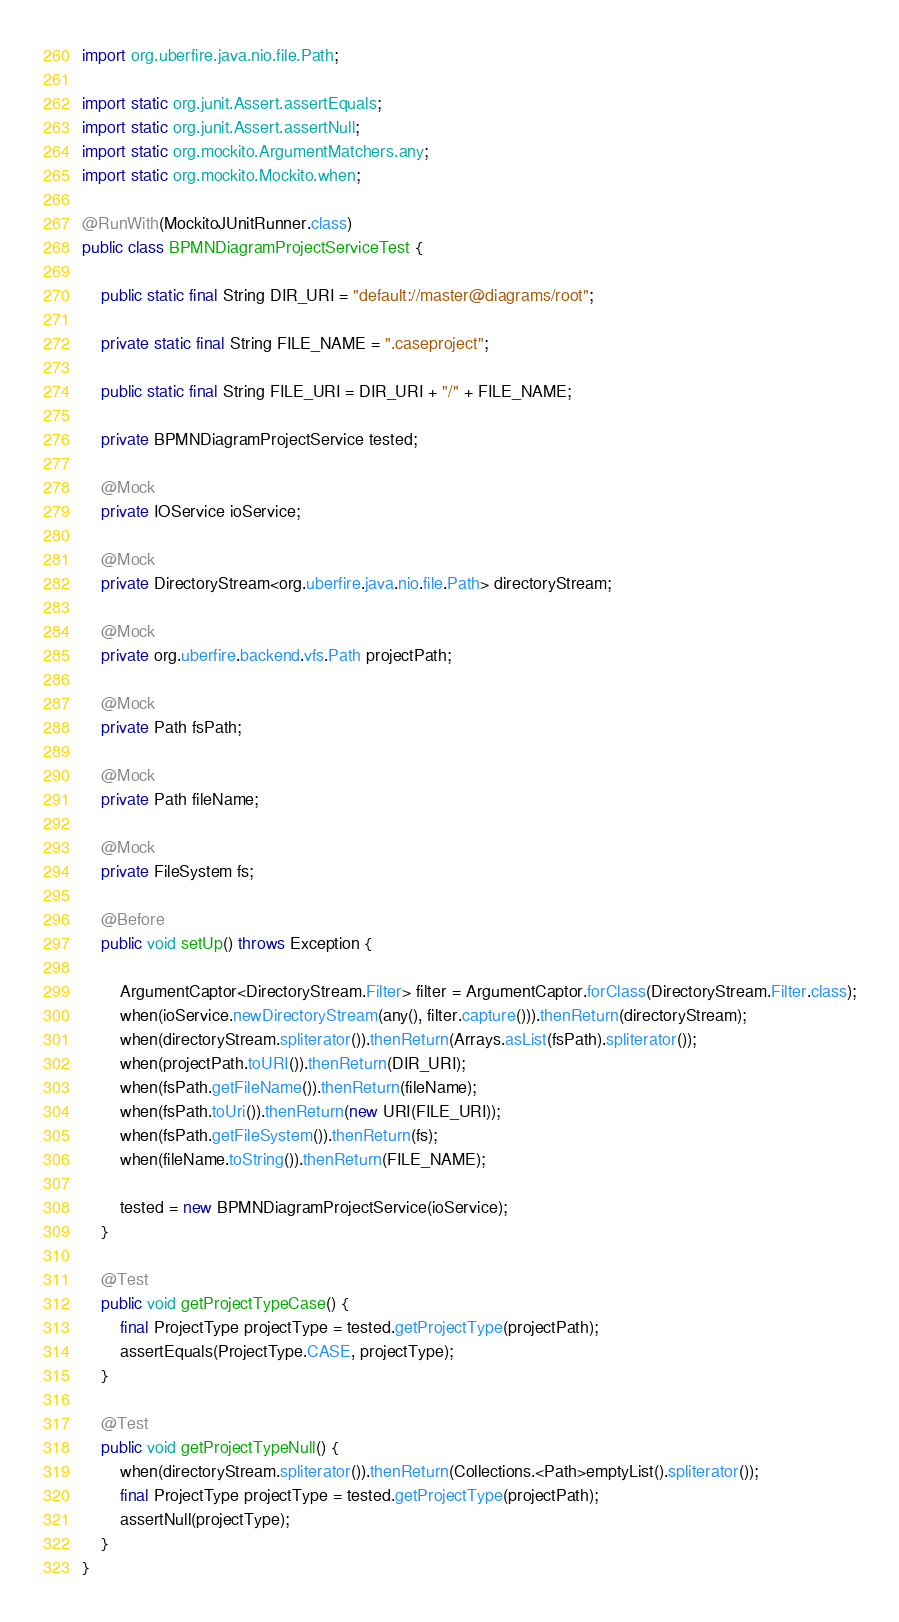<code> <loc_0><loc_0><loc_500><loc_500><_Java_>import org.uberfire.java.nio.file.Path;

import static org.junit.Assert.assertEquals;
import static org.junit.Assert.assertNull;
import static org.mockito.ArgumentMatchers.any;
import static org.mockito.Mockito.when;

@RunWith(MockitoJUnitRunner.class)
public class BPMNDiagramProjectServiceTest {

    public static final String DIR_URI = "default://master@diagrams/root";

    private static final String FILE_NAME = ".caseproject";

    public static final String FILE_URI = DIR_URI + "/" + FILE_NAME;

    private BPMNDiagramProjectService tested;

    @Mock
    private IOService ioService;

    @Mock
    private DirectoryStream<org.uberfire.java.nio.file.Path> directoryStream;

    @Mock
    private org.uberfire.backend.vfs.Path projectPath;

    @Mock
    private Path fsPath;

    @Mock
    private Path fileName;

    @Mock
    private FileSystem fs;

    @Before
    public void setUp() throws Exception {

        ArgumentCaptor<DirectoryStream.Filter> filter = ArgumentCaptor.forClass(DirectoryStream.Filter.class);
        when(ioService.newDirectoryStream(any(), filter.capture())).thenReturn(directoryStream);
        when(directoryStream.spliterator()).thenReturn(Arrays.asList(fsPath).spliterator());
        when(projectPath.toURI()).thenReturn(DIR_URI);
        when(fsPath.getFileName()).thenReturn(fileName);
        when(fsPath.toUri()).thenReturn(new URI(FILE_URI));
        when(fsPath.getFileSystem()).thenReturn(fs);
        when(fileName.toString()).thenReturn(FILE_NAME);

        tested = new BPMNDiagramProjectService(ioService);
    }

    @Test
    public void getProjectTypeCase() {
        final ProjectType projectType = tested.getProjectType(projectPath);
        assertEquals(ProjectType.CASE, projectType);
    }

    @Test
    public void getProjectTypeNull() {
        when(directoryStream.spliterator()).thenReturn(Collections.<Path>emptyList().spliterator());
        final ProjectType projectType = tested.getProjectType(projectPath);
        assertNull(projectType);
    }
}</code> 